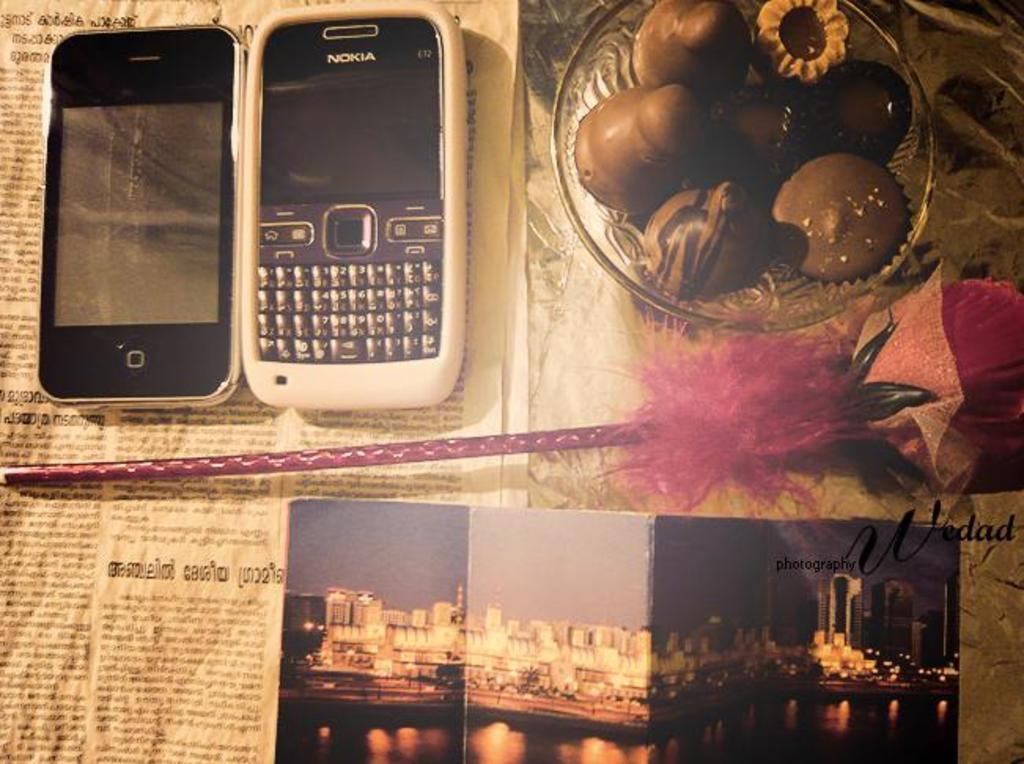<image>
Provide a brief description of the given image. A Nokia cell phone sits on top of a newspaper next to a bowl of food. 